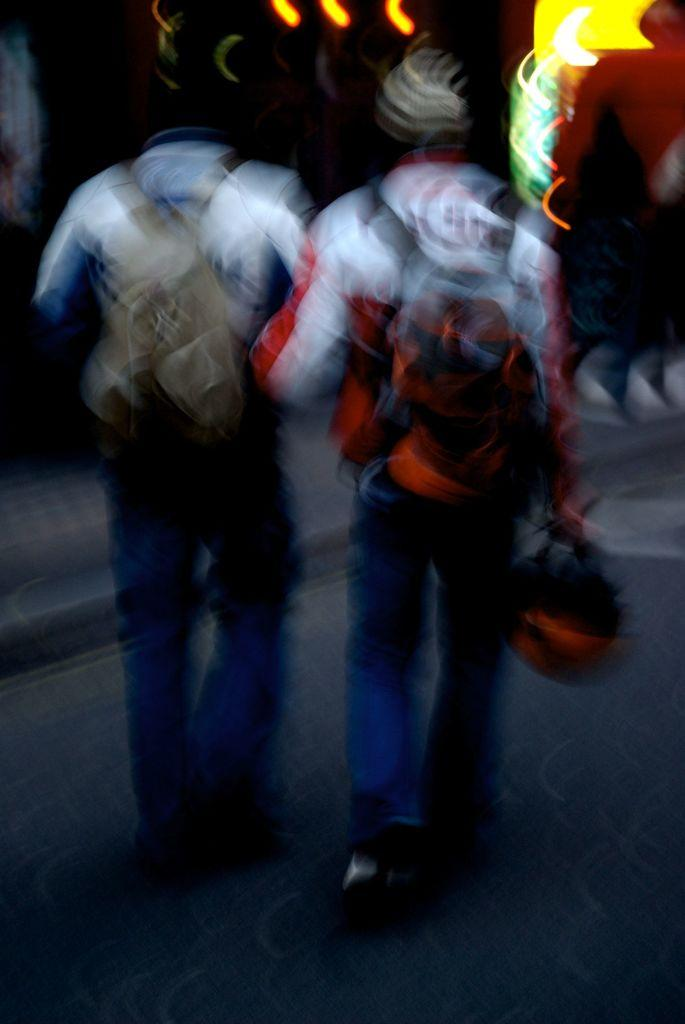How many people are in the image? There are two persons in the image. What are the two persons doing in the image? The two persons are walking. Can you describe the quality of the image? The image is blurry. What type of soup is being served by the actor in the image? There is no actor or soup present in the image; it features two persons walking. How many trees can be seen in the image? There are no trees visible in the image. 